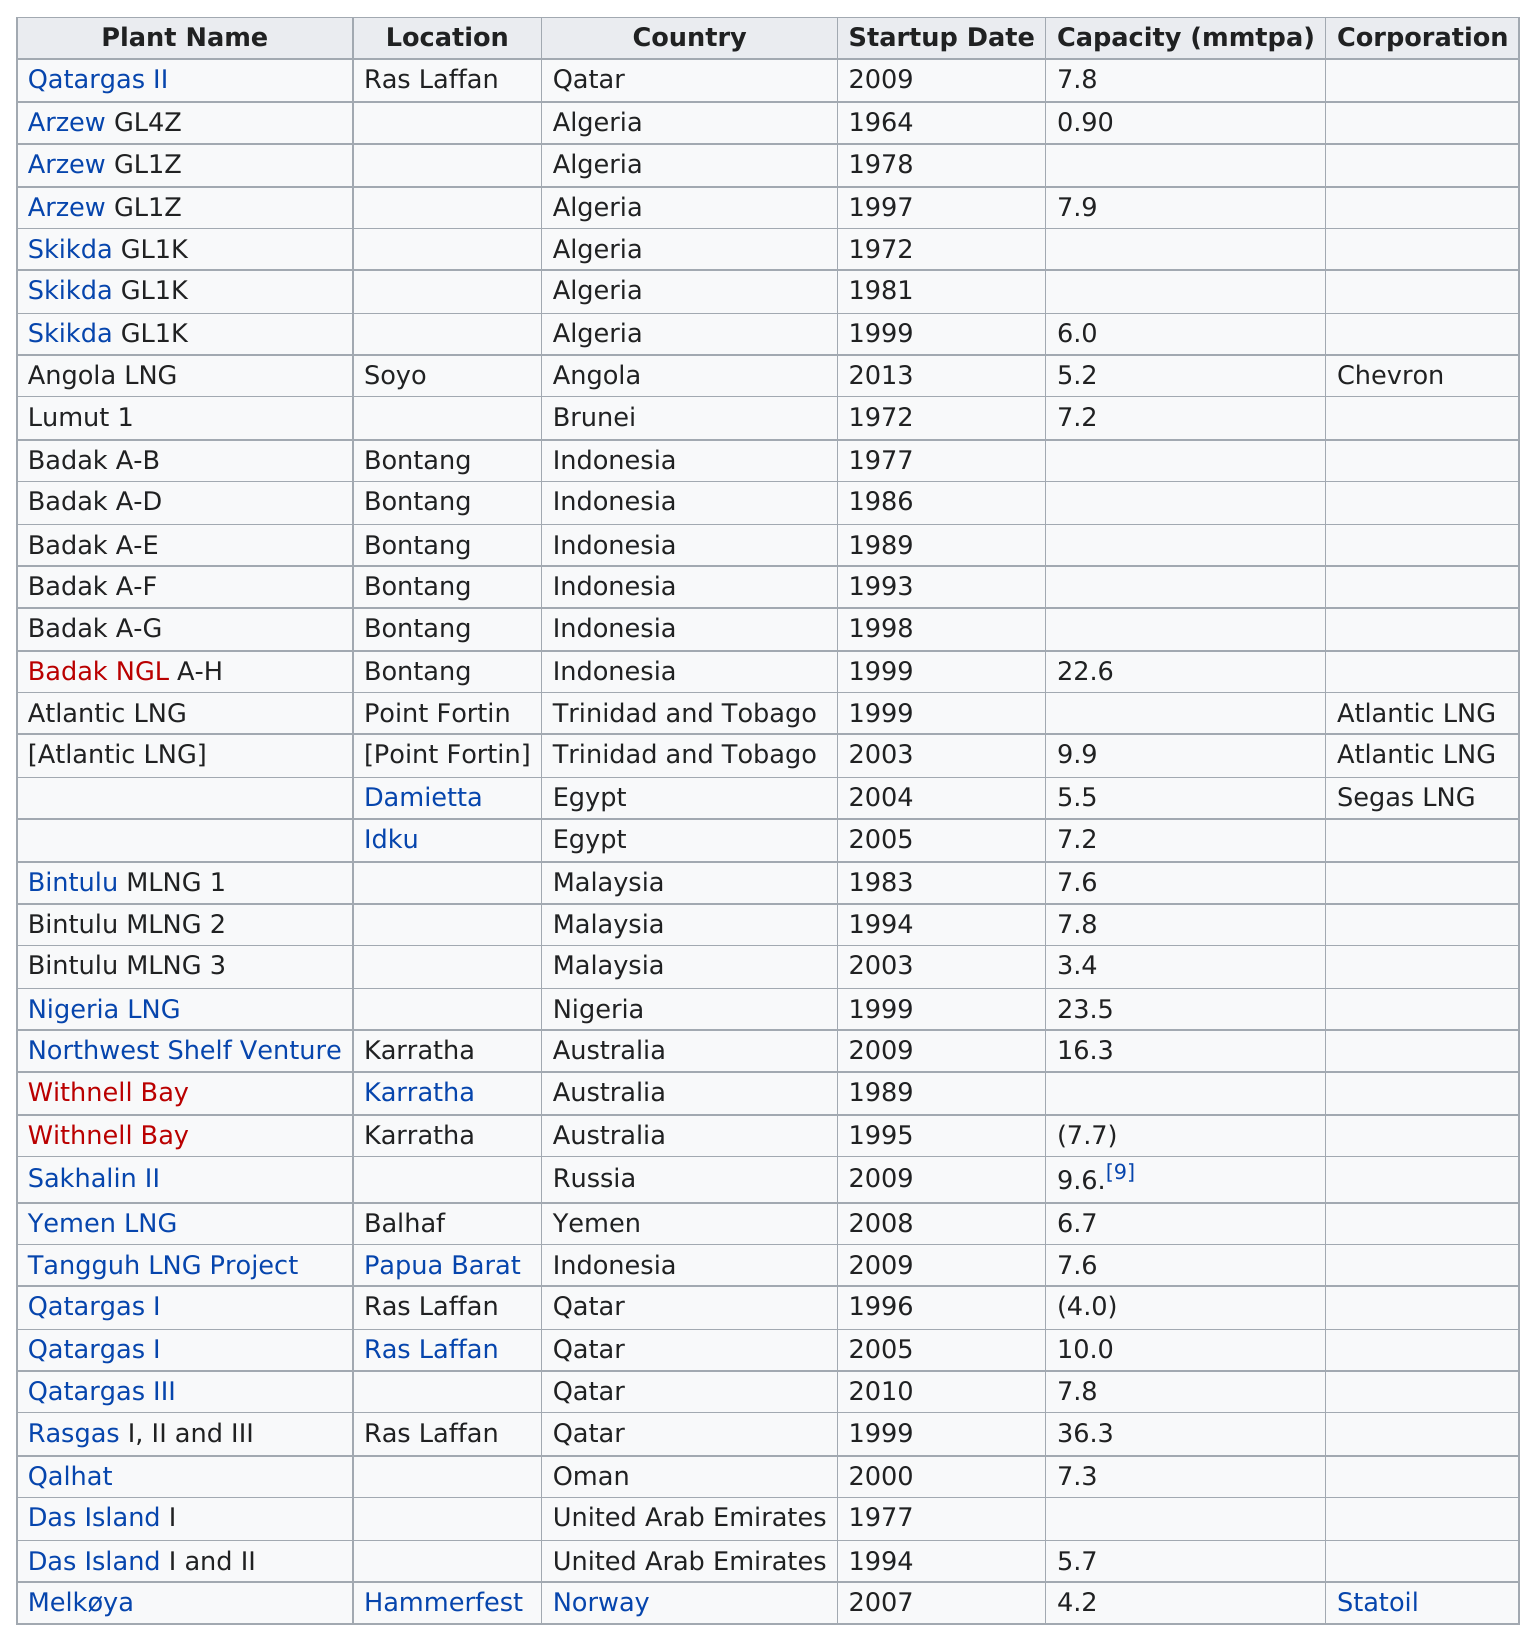Identify some key points in this picture. The total number of plants in Algeria is 6. Indonesia has the most plants. There are approximately 6 plants in Algeria. The number of plants in Algeria and the number of plants in Indonesia are different. Angola is the only country that started up a plant in 2013, making it a unique and noteworthy accomplishment in the world of industry. 